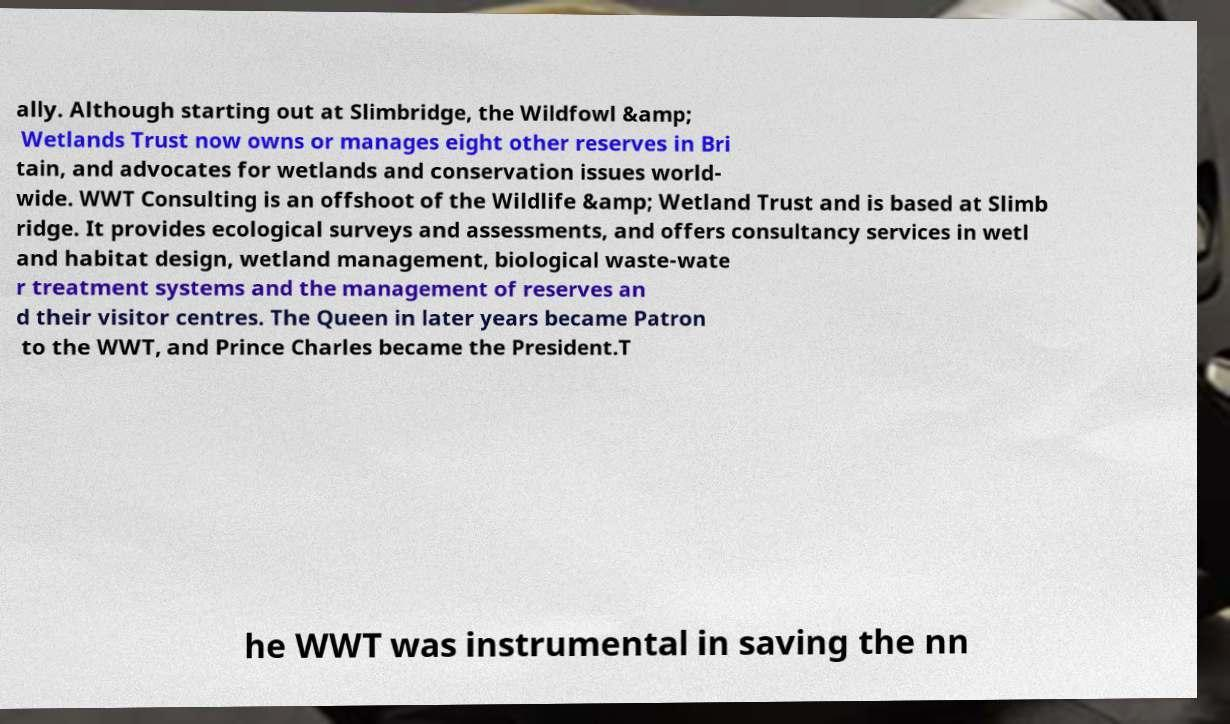Could you assist in decoding the text presented in this image and type it out clearly? ally. Although starting out at Slimbridge, the Wildfowl &amp; Wetlands Trust now owns or manages eight other reserves in Bri tain, and advocates for wetlands and conservation issues world- wide. WWT Consulting is an offshoot of the Wildlife &amp; Wetland Trust and is based at Slimb ridge. It provides ecological surveys and assessments, and offers consultancy services in wetl and habitat design, wetland management, biological waste-wate r treatment systems and the management of reserves an d their visitor centres. The Queen in later years became Patron to the WWT, and Prince Charles became the President.T he WWT was instrumental in saving the nn 